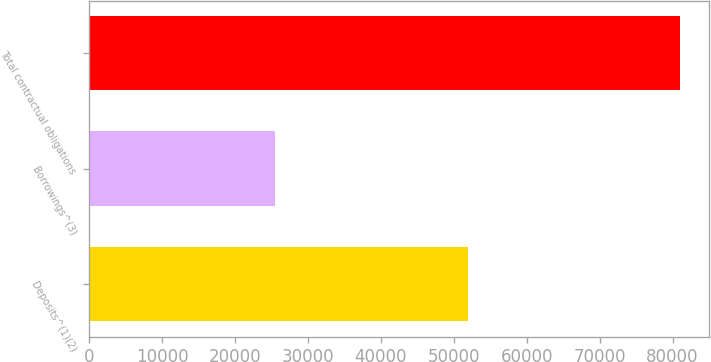Convert chart. <chart><loc_0><loc_0><loc_500><loc_500><bar_chart><fcel>Deposits^(1)(2)<fcel>Borrowings^(3)<fcel>Total contractual obligations<nl><fcel>51992<fcel>25443<fcel>81007<nl></chart> 